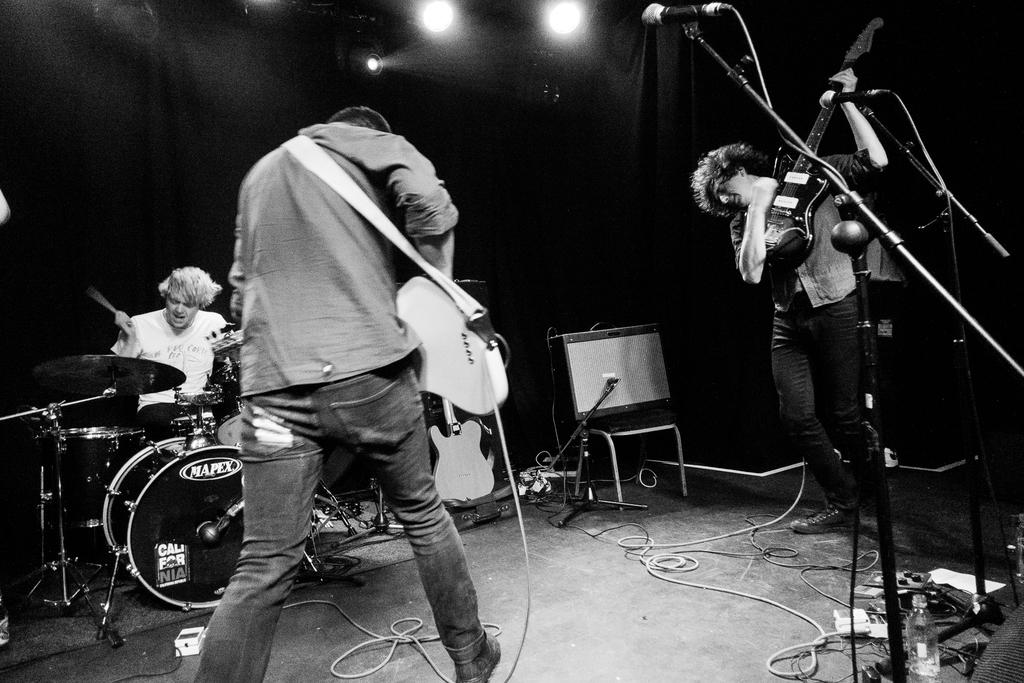What is the man in the image doing? The man is playing a guitar. Are there any other people in the image? Yes, there is another man in the image. What is the second man doing? The second man is playing a drum set. How many balls are visible in the image? There are no balls visible in the image. What type of coast can be seen in the background of the image? There is no coast present in the image; it is focused on the two men playing instruments. 